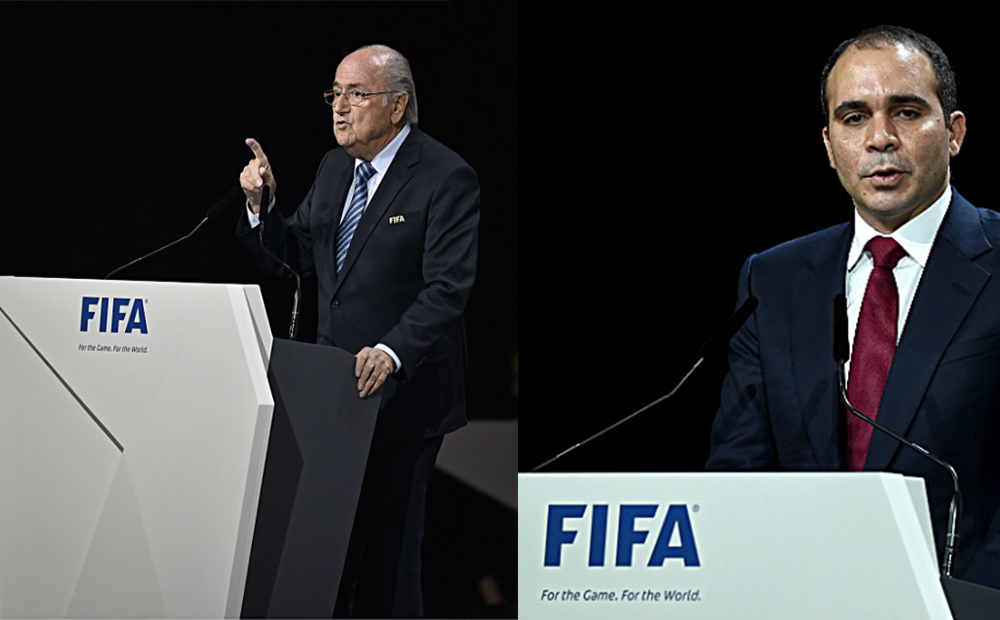Can you comment on the possible atmosphere in the room, given the expressions and postures observed in the image? The atmosphere seems solemn and formal, a setting where significant announcements or decisions might be communicated. The individuals' serious demeanors and professional attire suggest the matters discussed are of considerable importance, encouraging the audience to listen attentively and with respect. The ambient lighting appears to be muted, likely to maintain focus on the individuals, which may add to the gravity of the event. 